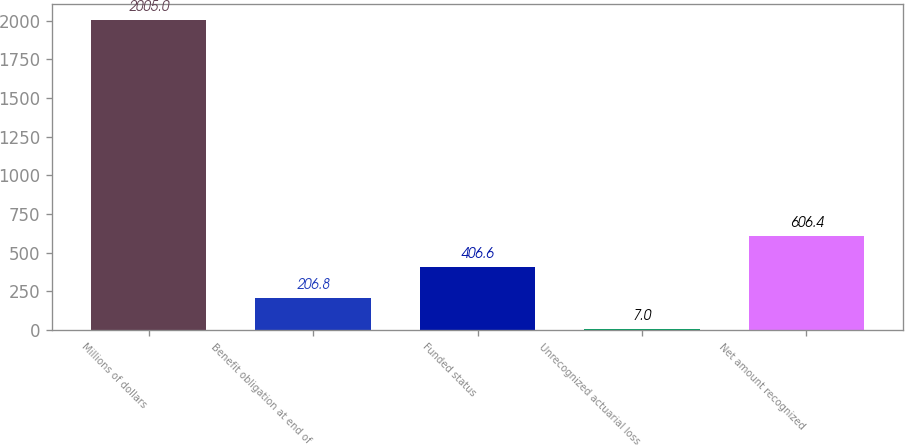<chart> <loc_0><loc_0><loc_500><loc_500><bar_chart><fcel>Millions of dollars<fcel>Benefit obligation at end of<fcel>Funded status<fcel>Unrecognized actuarial loss<fcel>Net amount recognized<nl><fcel>2005<fcel>206.8<fcel>406.6<fcel>7<fcel>606.4<nl></chart> 